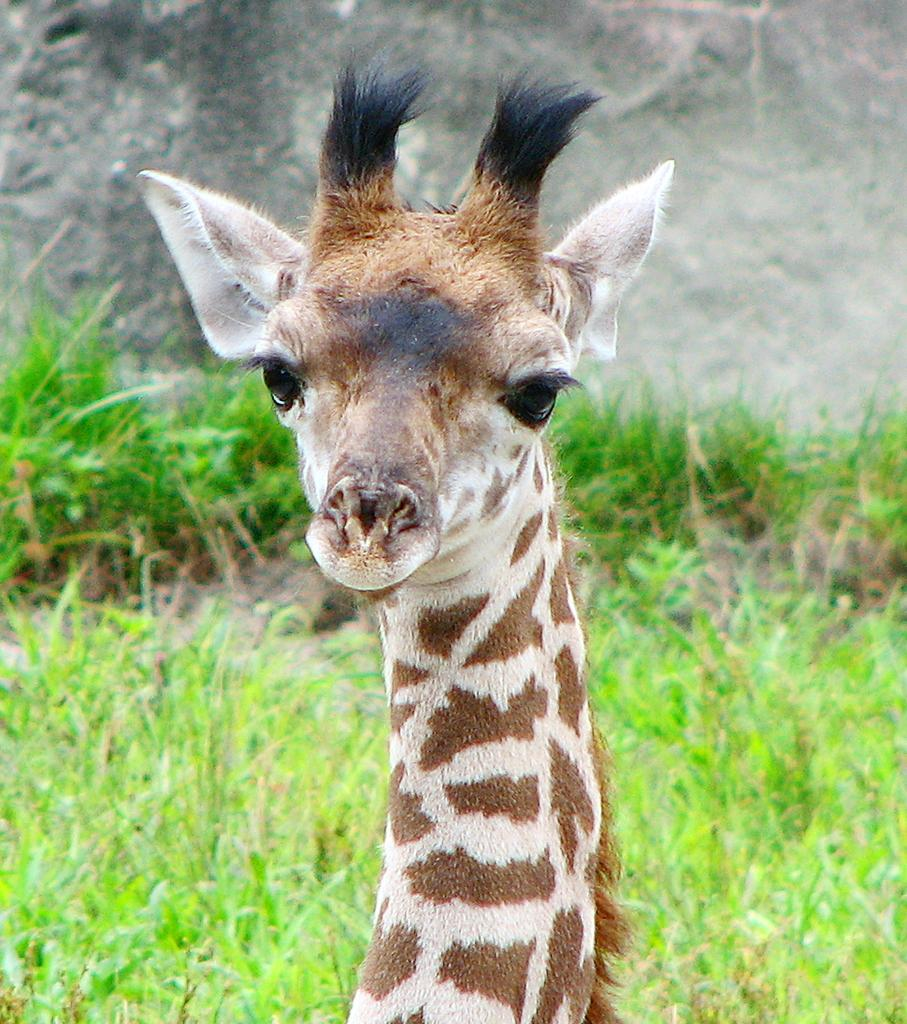What animal is present in the image? There is a giraffe in the image. What type of vegetation can be seen in the background of the image? There is green grass in the background of the image. What type of rose can be seen growing on the giraffe's neck in the image? There is no rose present in the image, and the giraffe's neck does not have any flowers growing on it. 